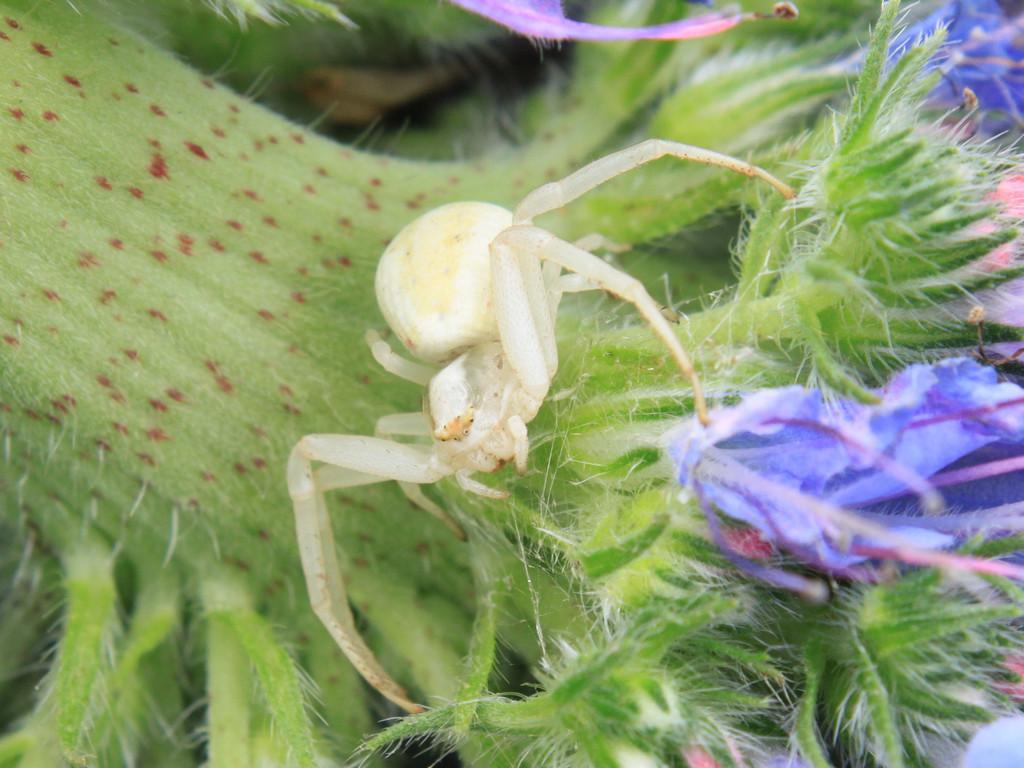What is present on the plant in the image? There is a spider on a plant in the image. What type of vegetation can be seen on the right side of the image? There are flowers on the right side of the image. How many boys are holding onto the spider in the image? There are no boys present in the image, and the spider is on a plant, not being held by anyone. 